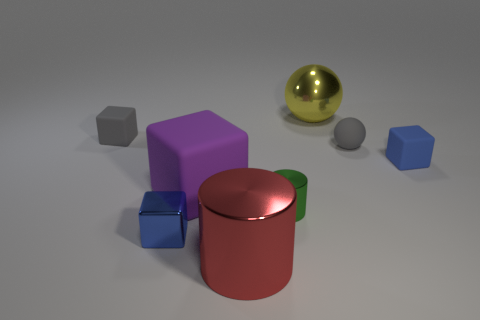What could the different objects in this picture represent if they were used metaphorically? Metaphorically, the objects could represent various elements of a community or society. The purple cube might symbolize stability and tradition, the red cylinder with its green band could stand for unity and growth, and the golden sphere may represent wealth or something of great value. The smaller cubes and spheres might be individuals or smaller entities that, while less conspicuous than the larger items, play crucial roles in the composition of the community. 